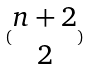<formula> <loc_0><loc_0><loc_500><loc_500>( \begin{matrix} n + 2 \\ 2 \end{matrix} )</formula> 